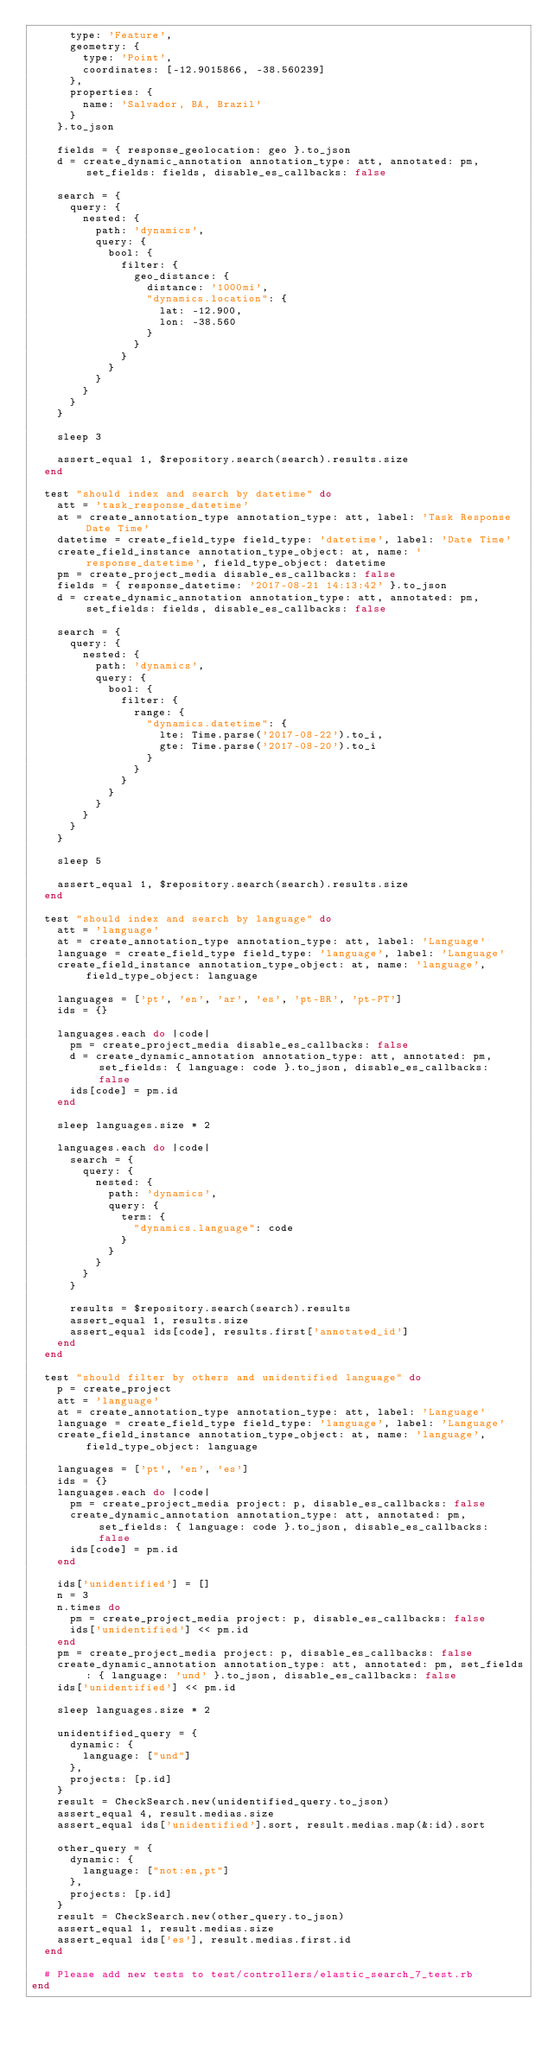Convert code to text. <code><loc_0><loc_0><loc_500><loc_500><_Ruby_>      type: 'Feature',
      geometry: {
        type: 'Point',
        coordinates: [-12.9015866, -38.560239]
      },
      properties: {
        name: 'Salvador, BA, Brazil'
      }
    }.to_json

    fields = { response_geolocation: geo }.to_json
    d = create_dynamic_annotation annotation_type: att, annotated: pm, set_fields: fields, disable_es_callbacks: false

    search = {
      query: {
        nested: {
          path: 'dynamics',
          query: {
            bool: {
              filter: {
                geo_distance: {
                  distance: '1000mi',
                  "dynamics.location": {
                    lat: -12.900,
                    lon: -38.560
                  }
                }
              }
            }
          }
        }
      }
    }

    sleep 3

    assert_equal 1, $repository.search(search).results.size
  end

  test "should index and search by datetime" do
    att = 'task_response_datetime'
    at = create_annotation_type annotation_type: att, label: 'Task Response Date Time'
    datetime = create_field_type field_type: 'datetime', label: 'Date Time'
    create_field_instance annotation_type_object: at, name: 'response_datetime', field_type_object: datetime
    pm = create_project_media disable_es_callbacks: false
    fields = { response_datetime: '2017-08-21 14:13:42' }.to_json
    d = create_dynamic_annotation annotation_type: att, annotated: pm, set_fields: fields, disable_es_callbacks: false

    search = {
      query: {
        nested: {
          path: 'dynamics',
          query: {
            bool: {
              filter: {
                range: {
                  "dynamics.datetime": {
                    lte: Time.parse('2017-08-22').to_i,
                    gte: Time.parse('2017-08-20').to_i
                  }
                }
              }
            }
          }
        }
      }
    }

    sleep 5

    assert_equal 1, $repository.search(search).results.size
  end

  test "should index and search by language" do
    att = 'language'
    at = create_annotation_type annotation_type: att, label: 'Language'
    language = create_field_type field_type: 'language', label: 'Language'
    create_field_instance annotation_type_object: at, name: 'language', field_type_object: language

    languages = ['pt', 'en', 'ar', 'es', 'pt-BR', 'pt-PT']
    ids = {}

    languages.each do |code|
      pm = create_project_media disable_es_callbacks: false
      d = create_dynamic_annotation annotation_type: att, annotated: pm, set_fields: { language: code }.to_json, disable_es_callbacks: false
      ids[code] = pm.id
    end

    sleep languages.size * 2

    languages.each do |code|
      search = {
        query: {
          nested: {
            path: 'dynamics',
            query: {
              term: {
                "dynamics.language": code
              }
            }
          }
        }
      }

      results = $repository.search(search).results
      assert_equal 1, results.size
      assert_equal ids[code], results.first['annotated_id']
    end
  end

  test "should filter by others and unidentified language" do
    p = create_project
    att = 'language'
    at = create_annotation_type annotation_type: att, label: 'Language'
    language = create_field_type field_type: 'language', label: 'Language'
    create_field_instance annotation_type_object: at, name: 'language', field_type_object: language

    languages = ['pt', 'en', 'es']
    ids = {}
    languages.each do |code|
      pm = create_project_media project: p, disable_es_callbacks: false
      create_dynamic_annotation annotation_type: att, annotated: pm, set_fields: { language: code }.to_json, disable_es_callbacks: false
      ids[code] = pm.id
    end

    ids['unidentified'] = []
    n = 3
    n.times do
      pm = create_project_media project: p, disable_es_callbacks: false
      ids['unidentified'] << pm.id
    end
    pm = create_project_media project: p, disable_es_callbacks: false
    create_dynamic_annotation annotation_type: att, annotated: pm, set_fields: { language: 'und' }.to_json, disable_es_callbacks: false
    ids['unidentified'] << pm.id

    sleep languages.size * 2

    unidentified_query = {
      dynamic: {
        language: ["und"]
      },
      projects: [p.id]
    }
    result = CheckSearch.new(unidentified_query.to_json)
    assert_equal 4, result.medias.size
    assert_equal ids['unidentified'].sort, result.medias.map(&:id).sort

    other_query = {
      dynamic: {
        language: ["not:en,pt"]
      },
      projects: [p.id]
    }
    result = CheckSearch.new(other_query.to_json)
    assert_equal 1, result.medias.size
    assert_equal ids['es'], result.medias.first.id
  end

  # Please add new tests to test/controllers/elastic_search_7_test.rb
end
</code> 